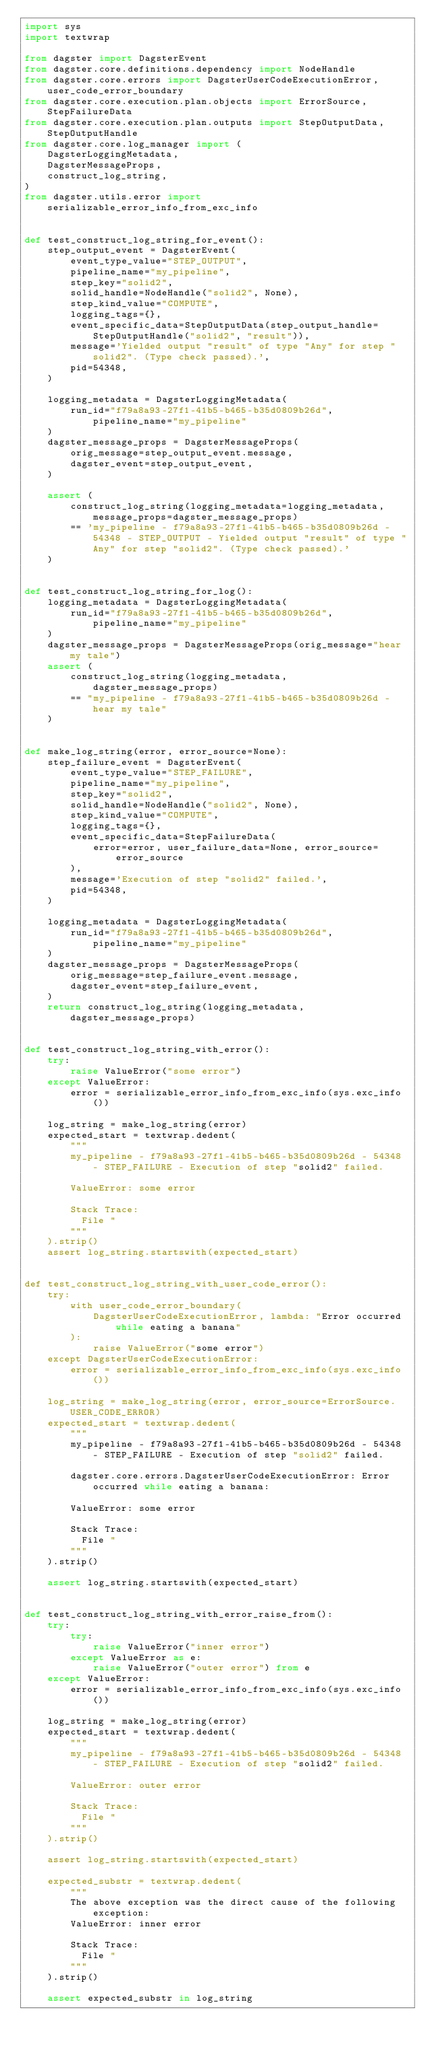<code> <loc_0><loc_0><loc_500><loc_500><_Python_>import sys
import textwrap

from dagster import DagsterEvent
from dagster.core.definitions.dependency import NodeHandle
from dagster.core.errors import DagsterUserCodeExecutionError, user_code_error_boundary
from dagster.core.execution.plan.objects import ErrorSource, StepFailureData
from dagster.core.execution.plan.outputs import StepOutputData, StepOutputHandle
from dagster.core.log_manager import (
    DagsterLoggingMetadata,
    DagsterMessageProps,
    construct_log_string,
)
from dagster.utils.error import serializable_error_info_from_exc_info


def test_construct_log_string_for_event():
    step_output_event = DagsterEvent(
        event_type_value="STEP_OUTPUT",
        pipeline_name="my_pipeline",
        step_key="solid2",
        solid_handle=NodeHandle("solid2", None),
        step_kind_value="COMPUTE",
        logging_tags={},
        event_specific_data=StepOutputData(step_output_handle=StepOutputHandle("solid2", "result")),
        message='Yielded output "result" of type "Any" for step "solid2". (Type check passed).',
        pid=54348,
    )

    logging_metadata = DagsterLoggingMetadata(
        run_id="f79a8a93-27f1-41b5-b465-b35d0809b26d", pipeline_name="my_pipeline"
    )
    dagster_message_props = DagsterMessageProps(
        orig_message=step_output_event.message,
        dagster_event=step_output_event,
    )

    assert (
        construct_log_string(logging_metadata=logging_metadata, message_props=dagster_message_props)
        == 'my_pipeline - f79a8a93-27f1-41b5-b465-b35d0809b26d - 54348 - STEP_OUTPUT - Yielded output "result" of type "Any" for step "solid2". (Type check passed).'
    )


def test_construct_log_string_for_log():
    logging_metadata = DagsterLoggingMetadata(
        run_id="f79a8a93-27f1-41b5-b465-b35d0809b26d", pipeline_name="my_pipeline"
    )
    dagster_message_props = DagsterMessageProps(orig_message="hear my tale")
    assert (
        construct_log_string(logging_metadata, dagster_message_props)
        == "my_pipeline - f79a8a93-27f1-41b5-b465-b35d0809b26d - hear my tale"
    )


def make_log_string(error, error_source=None):
    step_failure_event = DagsterEvent(
        event_type_value="STEP_FAILURE",
        pipeline_name="my_pipeline",
        step_key="solid2",
        solid_handle=NodeHandle("solid2", None),
        step_kind_value="COMPUTE",
        logging_tags={},
        event_specific_data=StepFailureData(
            error=error, user_failure_data=None, error_source=error_source
        ),
        message='Execution of step "solid2" failed.',
        pid=54348,
    )

    logging_metadata = DagsterLoggingMetadata(
        run_id="f79a8a93-27f1-41b5-b465-b35d0809b26d", pipeline_name="my_pipeline"
    )
    dagster_message_props = DagsterMessageProps(
        orig_message=step_failure_event.message,
        dagster_event=step_failure_event,
    )
    return construct_log_string(logging_metadata, dagster_message_props)


def test_construct_log_string_with_error():
    try:
        raise ValueError("some error")
    except ValueError:
        error = serializable_error_info_from_exc_info(sys.exc_info())

    log_string = make_log_string(error)
    expected_start = textwrap.dedent(
        """
        my_pipeline - f79a8a93-27f1-41b5-b465-b35d0809b26d - 54348 - STEP_FAILURE - Execution of step "solid2" failed.

        ValueError: some error

        Stack Trace:
          File "
        """
    ).strip()
    assert log_string.startswith(expected_start)


def test_construct_log_string_with_user_code_error():
    try:
        with user_code_error_boundary(
            DagsterUserCodeExecutionError, lambda: "Error occurred while eating a banana"
        ):
            raise ValueError("some error")
    except DagsterUserCodeExecutionError:
        error = serializable_error_info_from_exc_info(sys.exc_info())

    log_string = make_log_string(error, error_source=ErrorSource.USER_CODE_ERROR)
    expected_start = textwrap.dedent(
        """
        my_pipeline - f79a8a93-27f1-41b5-b465-b35d0809b26d - 54348 - STEP_FAILURE - Execution of step "solid2" failed.

        dagster.core.errors.DagsterUserCodeExecutionError: Error occurred while eating a banana:

        ValueError: some error

        Stack Trace:
          File "
        """
    ).strip()

    assert log_string.startswith(expected_start)


def test_construct_log_string_with_error_raise_from():
    try:
        try:
            raise ValueError("inner error")
        except ValueError as e:
            raise ValueError("outer error") from e
    except ValueError:
        error = serializable_error_info_from_exc_info(sys.exc_info())

    log_string = make_log_string(error)
    expected_start = textwrap.dedent(
        """
        my_pipeline - f79a8a93-27f1-41b5-b465-b35d0809b26d - 54348 - STEP_FAILURE - Execution of step "solid2" failed.

        ValueError: outer error

        Stack Trace:
          File "
        """
    ).strip()

    assert log_string.startswith(expected_start)

    expected_substr = textwrap.dedent(
        """
        The above exception was the direct cause of the following exception:
        ValueError: inner error

        Stack Trace:
          File "
        """
    ).strip()

    assert expected_substr in log_string
</code> 